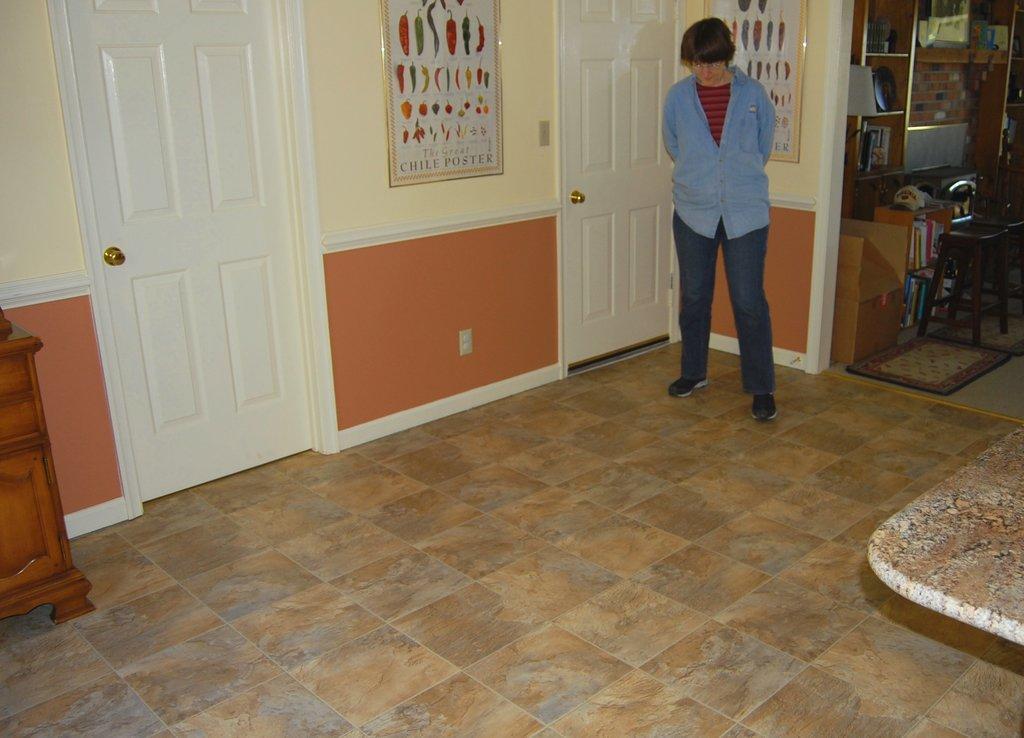Could you give a brief overview of what you see in this image? In this picture we can see a person is standing on the floor. On the left side of the person there are doors and there are photo frames attached to the wall. On the left side of the image, it looks like a wooden cupboard. On the right side of the image, there is a stool, cardboard box, carpet and some objects. 